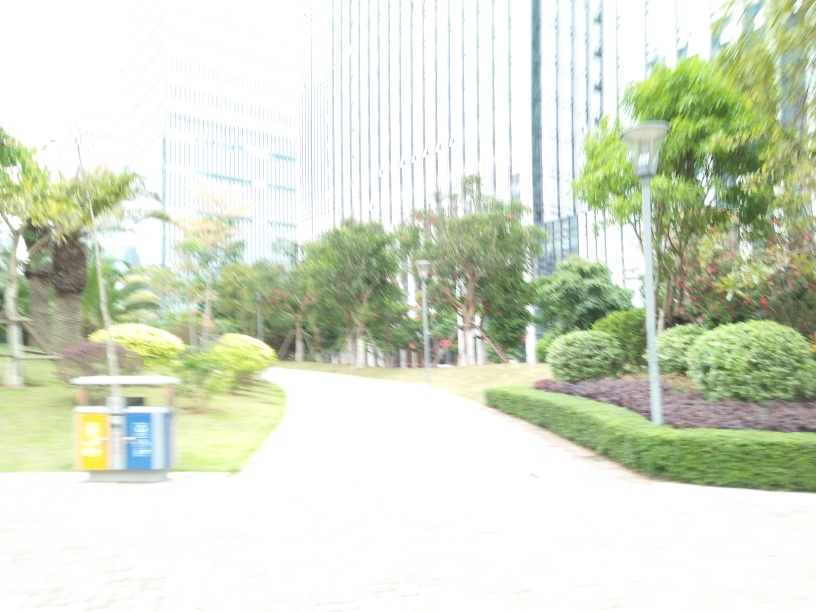Are the outlines of the buildings clear? The outlines of the buildings are not clear due to the image being overexposed and lacking in sharpness. This results in a loss of detail which prevents clear visibility of the buildings' edges. 